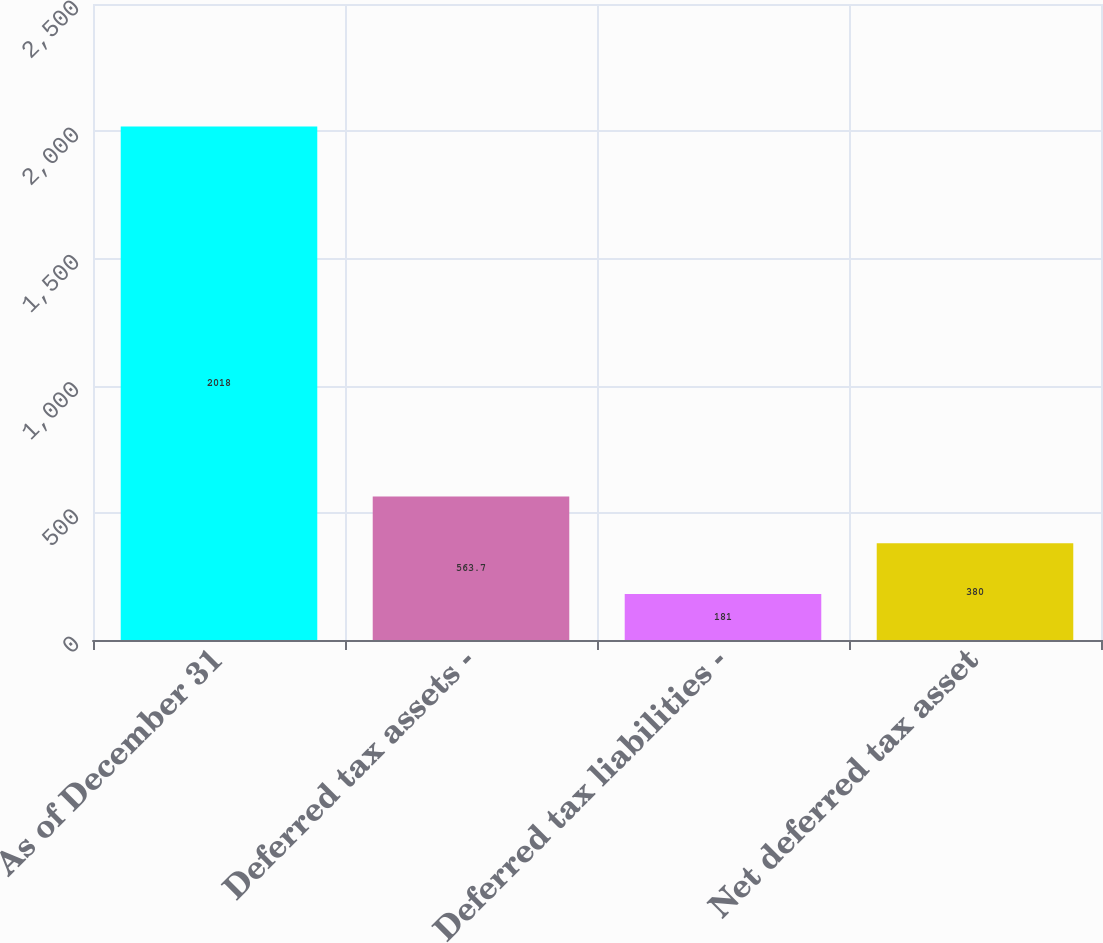<chart> <loc_0><loc_0><loc_500><loc_500><bar_chart><fcel>As of December 31<fcel>Deferred tax assets -<fcel>Deferred tax liabilities -<fcel>Net deferred tax asset<nl><fcel>2018<fcel>563.7<fcel>181<fcel>380<nl></chart> 